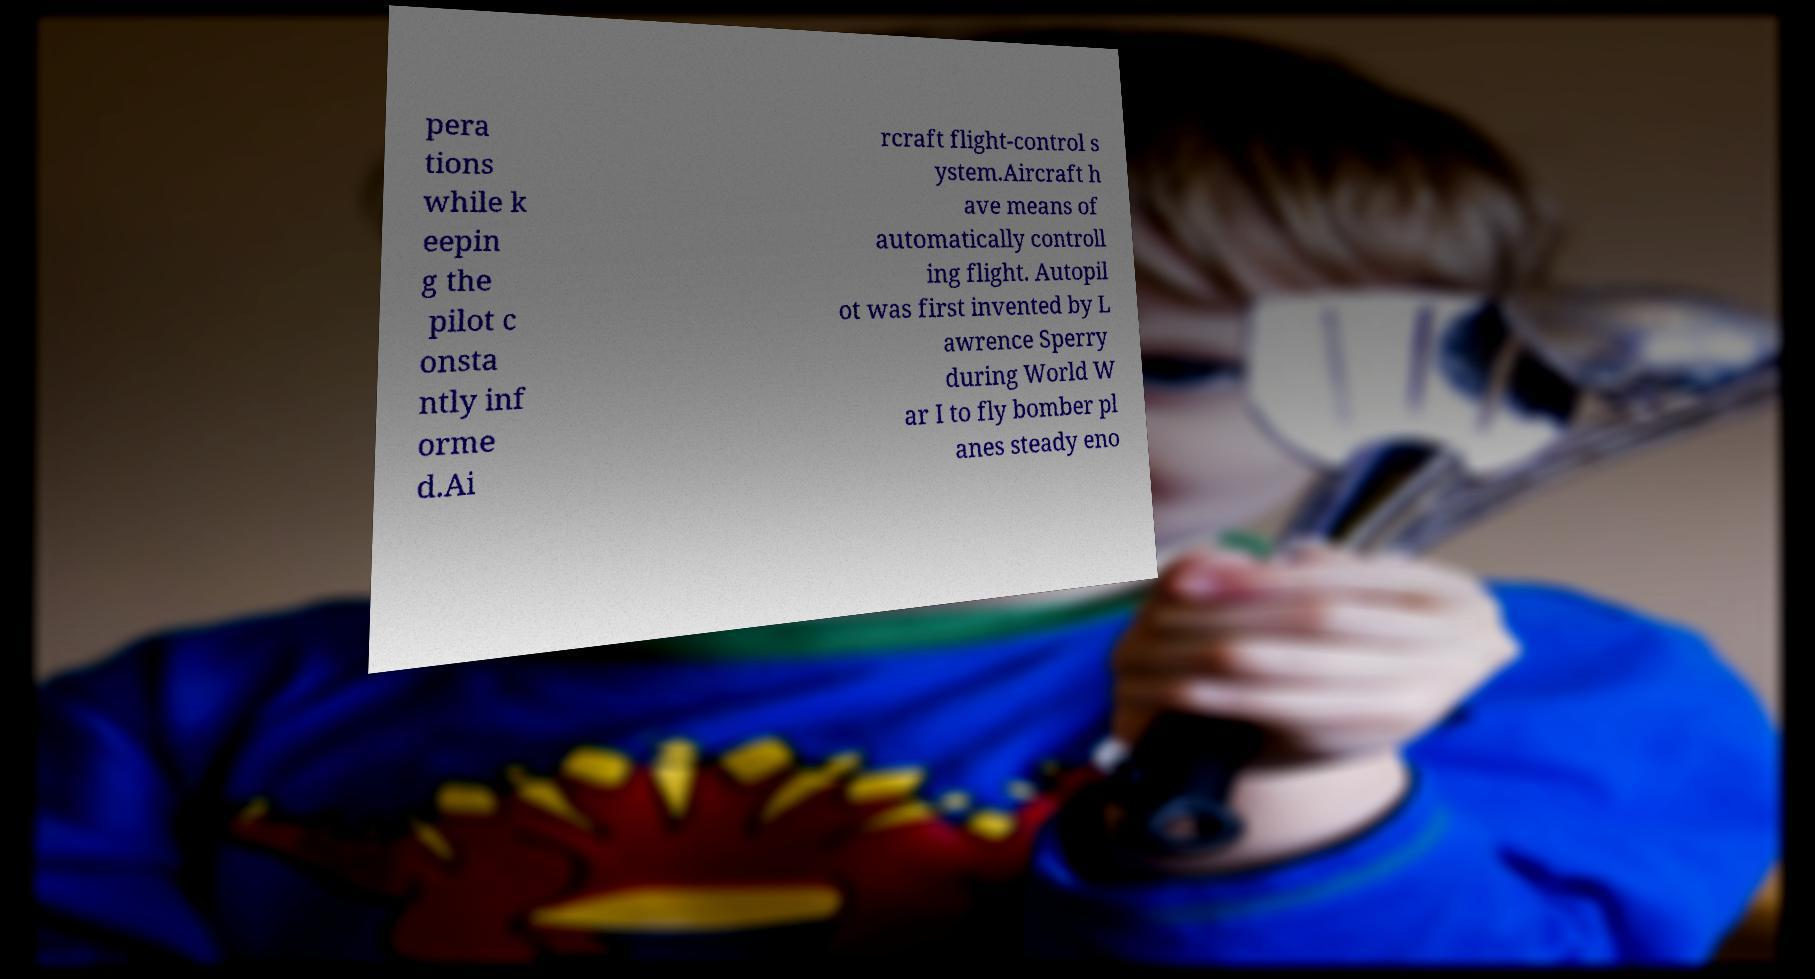Can you read and provide the text displayed in the image?This photo seems to have some interesting text. Can you extract and type it out for me? pera tions while k eepin g the pilot c onsta ntly inf orme d.Ai rcraft flight-control s ystem.Aircraft h ave means of automatically controll ing flight. Autopil ot was first invented by L awrence Sperry during World W ar I to fly bomber pl anes steady eno 